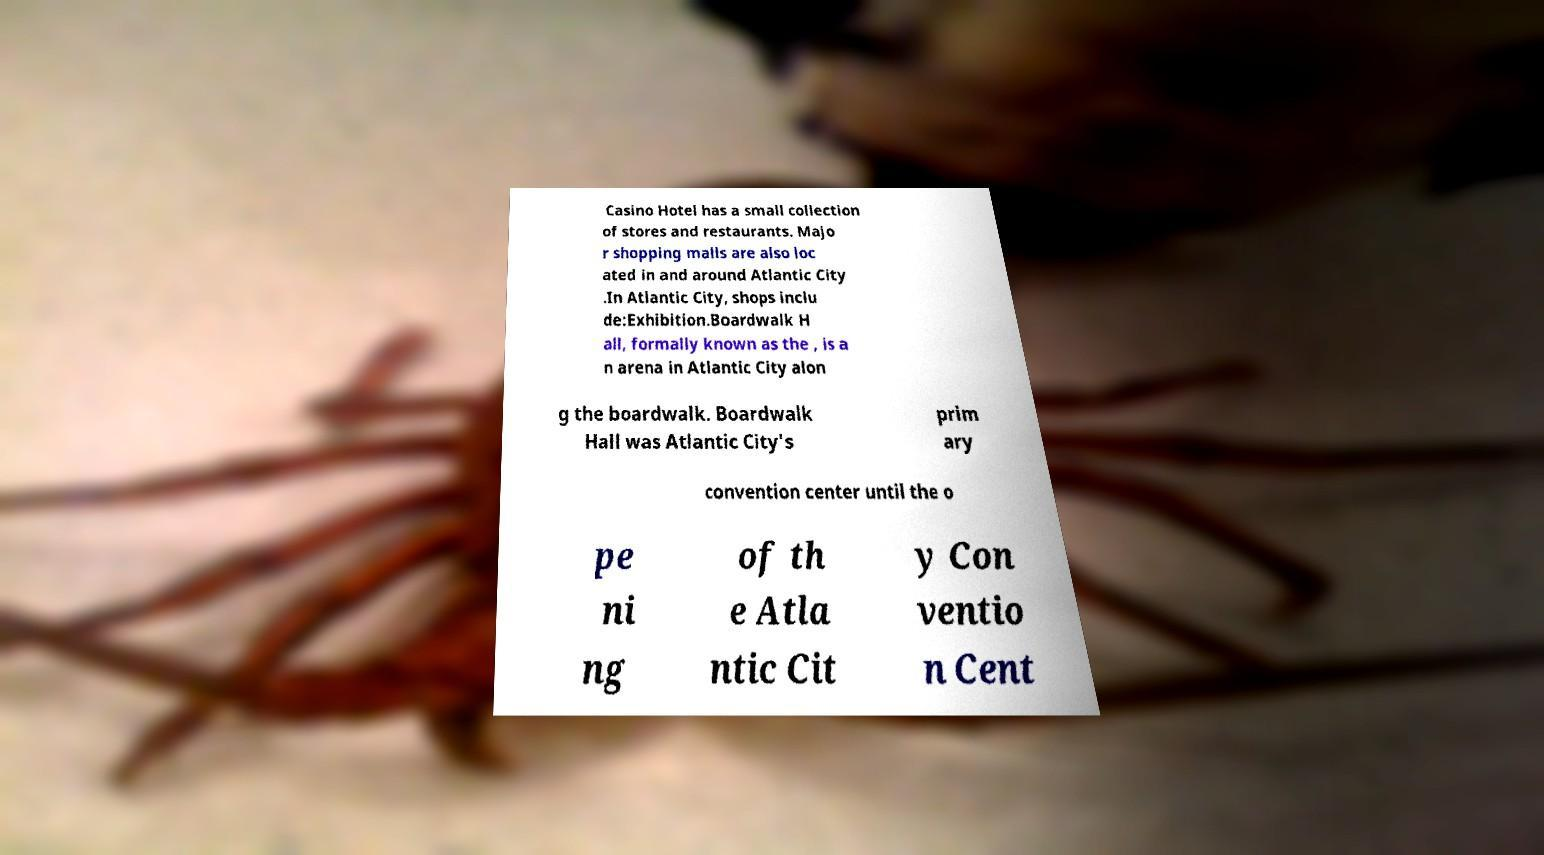What messages or text are displayed in this image? I need them in a readable, typed format. Casino Hotel has a small collection of stores and restaurants. Majo r shopping malls are also loc ated in and around Atlantic City .In Atlantic City, shops inclu de:Exhibition.Boardwalk H all, formally known as the , is a n arena in Atlantic City alon g the boardwalk. Boardwalk Hall was Atlantic City's prim ary convention center until the o pe ni ng of th e Atla ntic Cit y Con ventio n Cent 